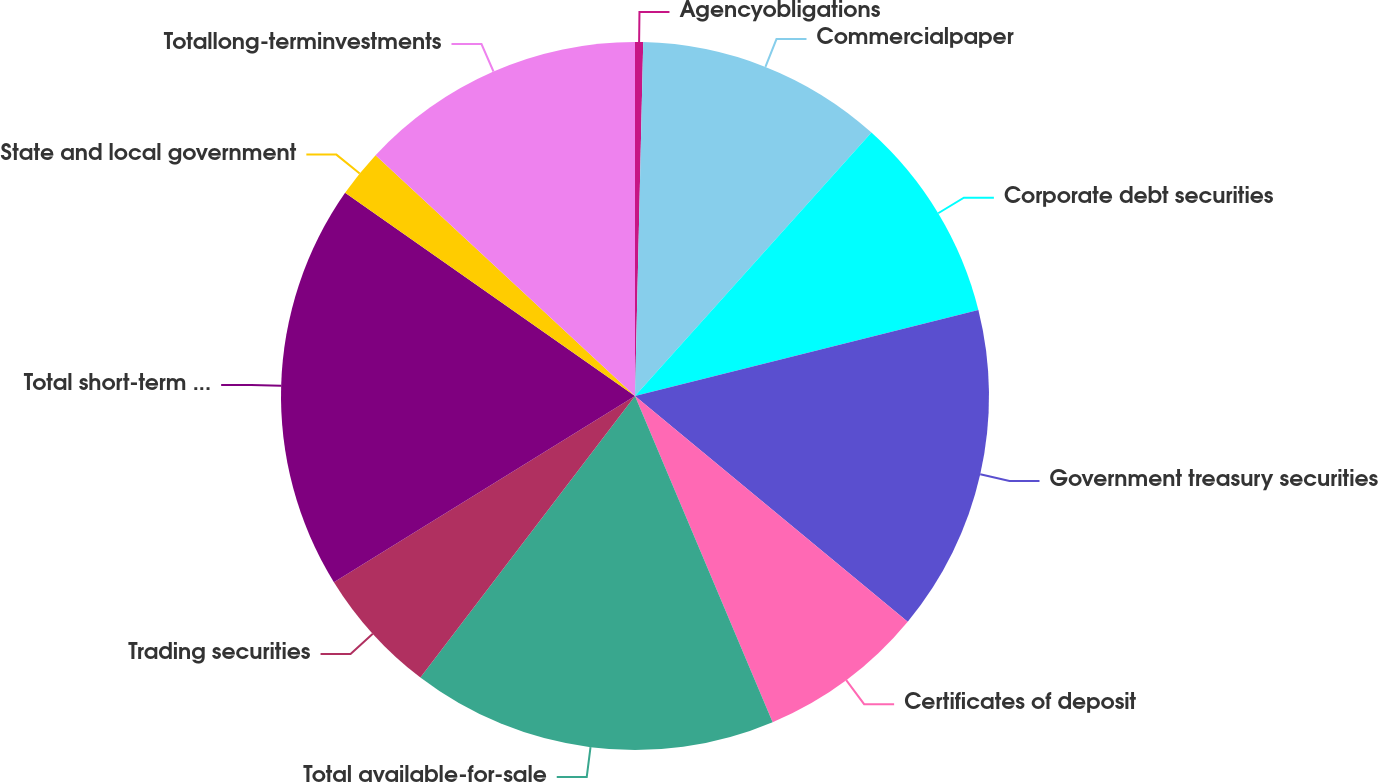<chart> <loc_0><loc_0><loc_500><loc_500><pie_chart><fcel>Agencyobligations<fcel>Commercialpaper<fcel>Corporate debt securities<fcel>Government treasury securities<fcel>Certificates of deposit<fcel>Total available-for-sale<fcel>Trading securities<fcel>Total short-term investments<fcel>State and local government<fcel>Totallong-terminvestments<nl><fcel>0.37%<fcel>11.27%<fcel>9.45%<fcel>14.91%<fcel>7.64%<fcel>16.72%<fcel>5.82%<fcel>18.54%<fcel>2.18%<fcel>13.09%<nl></chart> 